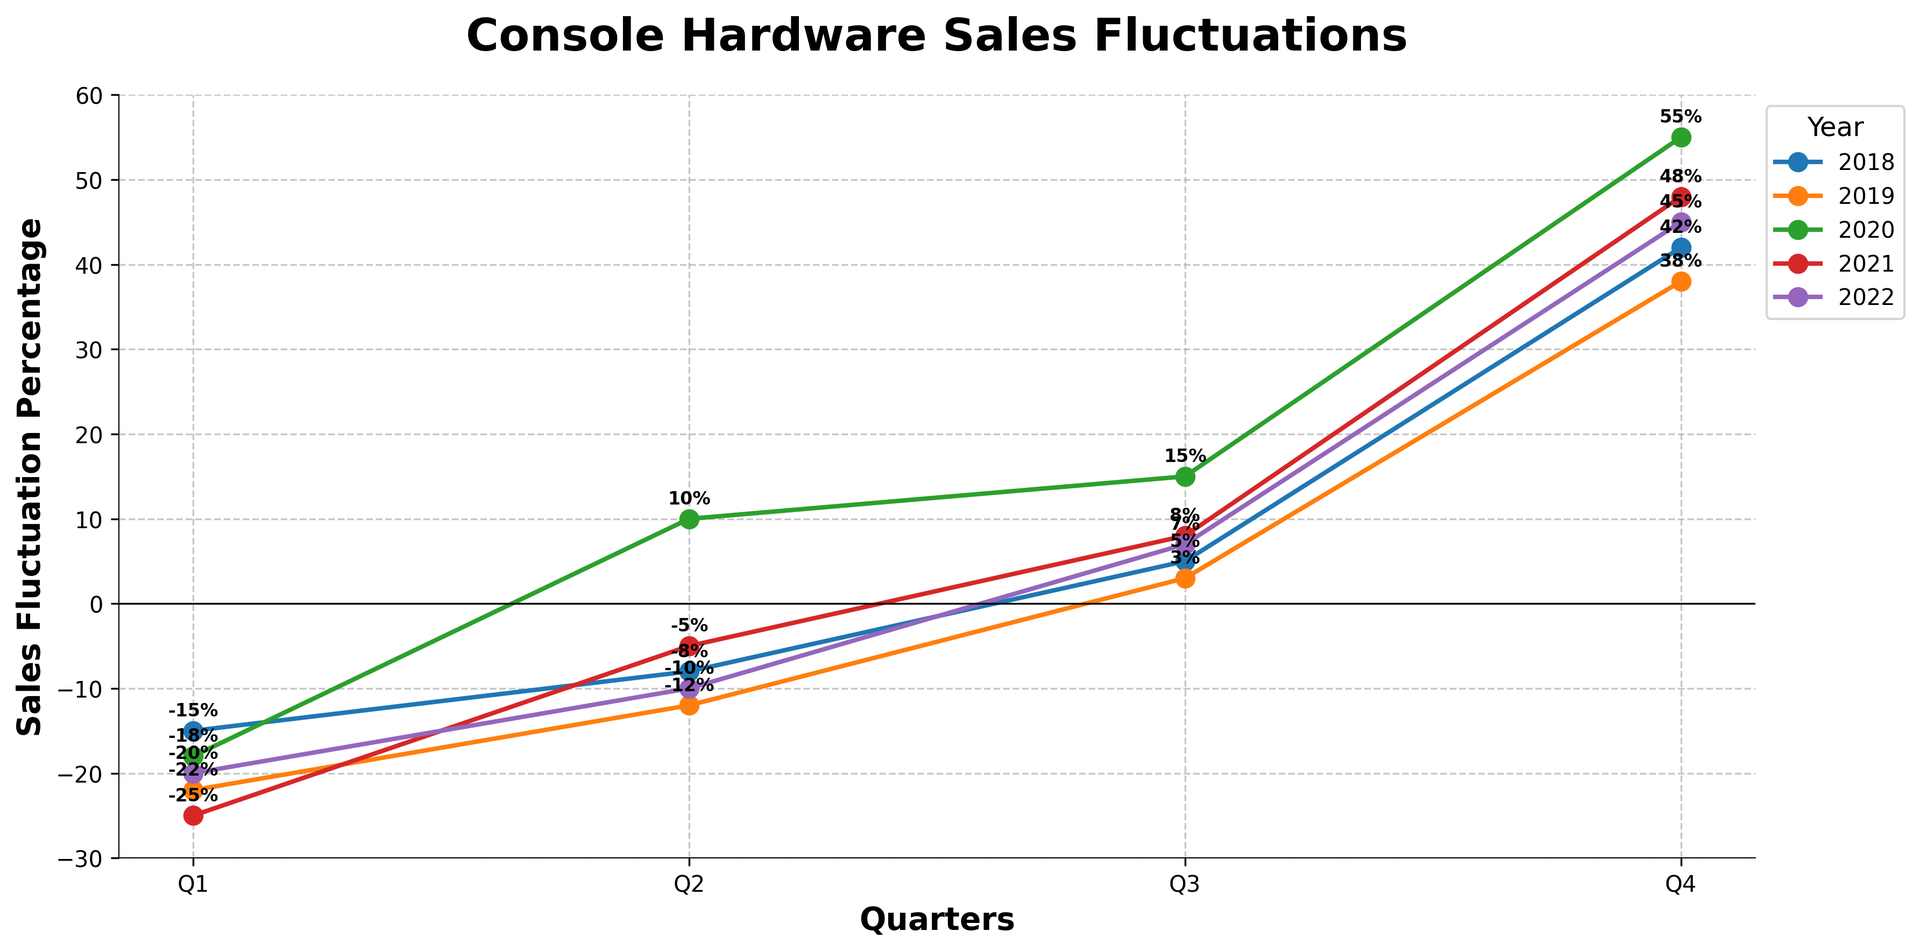Which quarter in 2020 had the highest sales fluctuation percentage? The highest sales fluctuation percentage in 2020 is 55% in Q4. This can be observed as the highest point on the 2020 line in the chart.
Answer: Q4 How do the sales fluctuation percentages compare between Q4 of 2020 and Q4 of 2021? In Q4 of 2020, the sales fluctuation percentage was 55%, while in Q4 of 2021, it was 48%. This can be seen by comparing the points on the chart for these specific quarters.
Answer: 55% in 2020, 48% in 2021 What is the average sales fluctuation percentage for Q4 across all the years? The sales fluctuation percentages for Q4 are 42%, 38%, 55%, 48%, and 45% for the years 2018, 2019, 2020, 2021, and 2022, respectively. Summing these gives us 228%, and dividing by 5 gives an average of 45.6%.
Answer: 45.6% Which year had the most significant negative sales fluctuation in any quarter, and what was the value and quarter? The most significant negative sales fluctuation occurred in Q1 of 2021 with -25%, as the lowest point on the chart for Q1 across all years.
Answer: 2021, Q1, -25% In which quarter does the trend of sales fluctuation typically invert from negative to positive? Generally, sales fluctuation trends from negative to positive between Q2 and Q3, as seen in multiple years where Q2 is negative or low positive and Q3 moves to a positive percentage.
Answer: Between Q2 and Q3 What is the overall trend in sales fluctuation percentages during Q4 from 2018 to 2022? Analyzing Q4 data from 2018 to 2022 shows an increasing trend: 42% in 2018, 38% in 2019, 55% in 2020, 48% in 2021, and 45% in 2022. Despite slight fluctuations, there is a general upward trend.
Answer: Increasing trend How does Q1 of 2019 compare to Q1 of 2018 in terms of sales fluctuation percentage? Q1 of 2019 had a sales fluctuation percentage of -22%, compared to -15% in Q1 of 2018. This indicates that the decline was steeper in 2019.
Answer: Steeper decline in 2019 Calculate the difference in sales fluctuation percentage between Q2 and Q4 of 2020. For 2020, Q2 had a sales fluctuation percentage of 10%, and Q4 had 55%. The difference is 55% - 10% = 45%.
Answer: 45% What visual pattern can be observed during holiday seasons for console hardware sales? During the holiday seasons, which correspond to Q4, there is a noticeable spike in sales fluctuation percentages across all years. This highlights increased sales activity typically seen during holidays.
Answer: Noticeable spike in Q4 